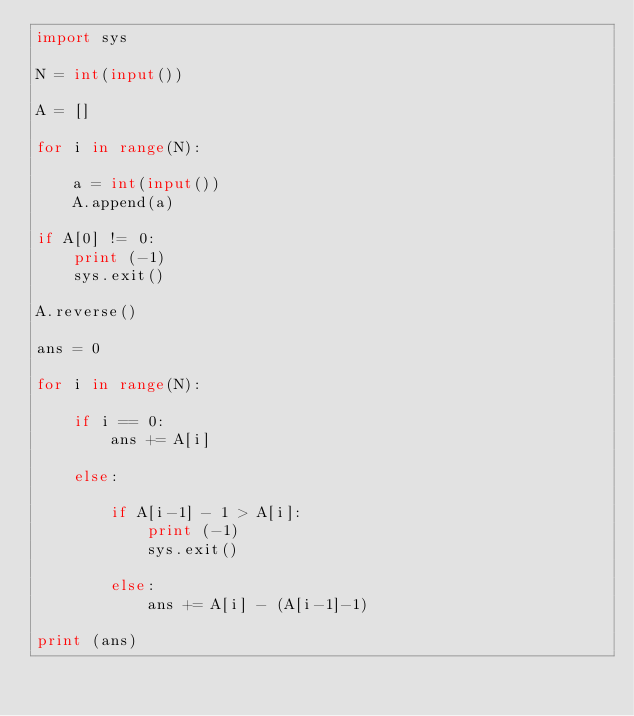<code> <loc_0><loc_0><loc_500><loc_500><_Python_>import sys

N = int(input())

A = []

for i in range(N):

    a = int(input())
    A.append(a)

if A[0] != 0:
    print (-1)
    sys.exit()

A.reverse()

ans = 0

for i in range(N):

    if i == 0:
        ans += A[i]

    else:

        if A[i-1] - 1 > A[i]:
            print (-1)
            sys.exit()

        else:
            ans += A[i] - (A[i-1]-1)

print (ans)
</code> 